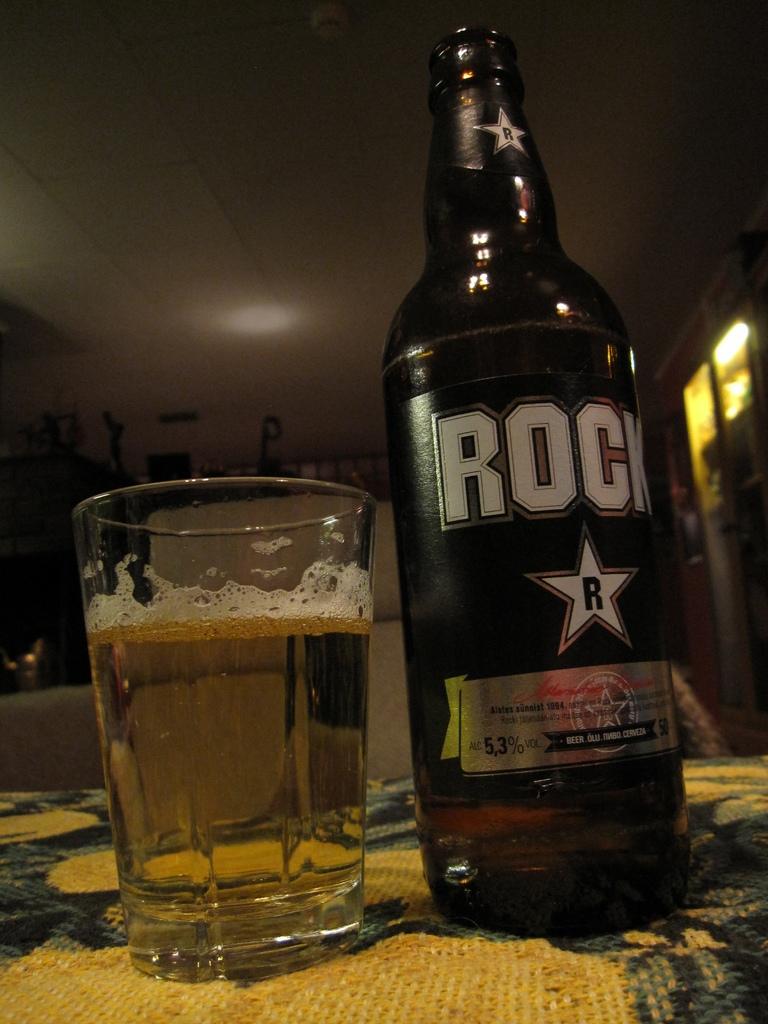What letter is inside the star?
Ensure brevity in your answer.  R. What is the name of the beer in the dark colored bottle?
Make the answer very short. Rock. 